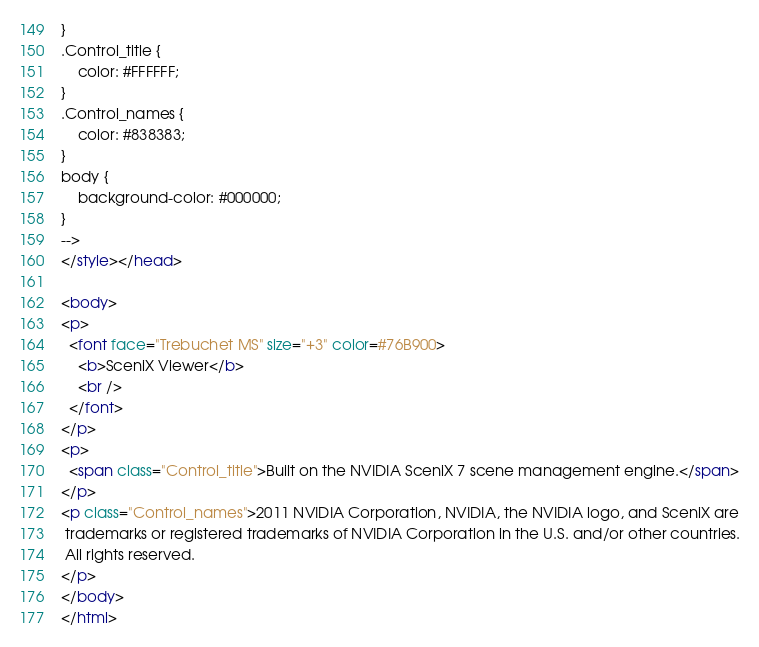Convert code to text. <code><loc_0><loc_0><loc_500><loc_500><_HTML_>}
.Control_title {
	color: #FFFFFF;
}
.Control_names {
	color: #838383;
}
body {
	background-color: #000000;
}
-->
</style></head>

<body>
<p>
  <font face="Trebuchet MS" size="+3" color=#76B900>  
    <b>SceniX Viewer</b> 
    <br />
  </font>
</p>
<p>
  <span class="Control_title">Built on the NVIDIA SceniX 7 scene management engine.</span>
</p>
<p class="Control_names">2011 NVIDIA Corporation, NVIDIA, the NVIDIA logo, and SceniX are
 trademarks or registered trademarks of NVIDIA Corporation in the U.S. and/or other countries.
 All rights reserved.
</p>
</body>
</html>
</code> 